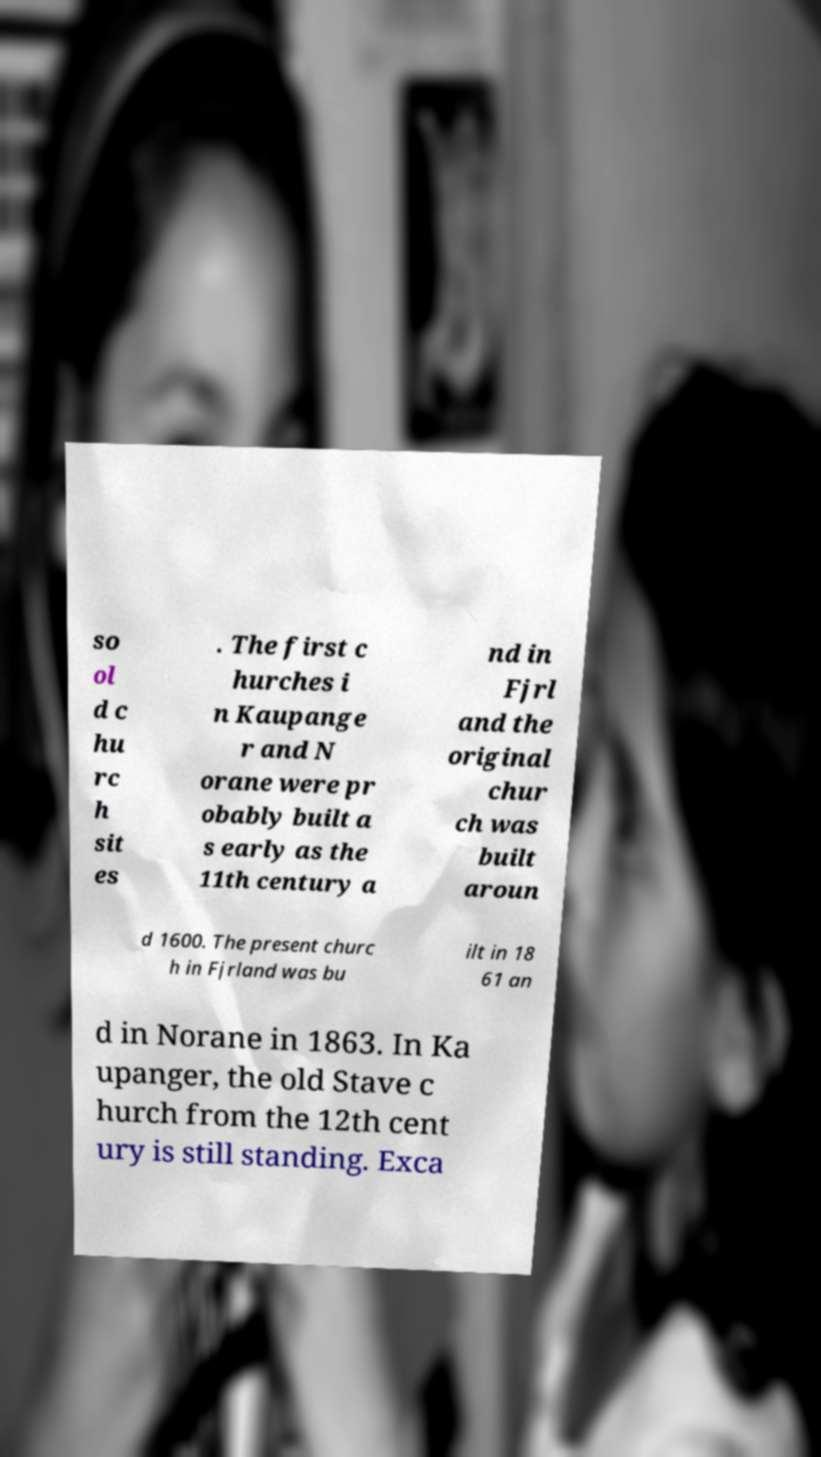Can you accurately transcribe the text from the provided image for me? so ol d c hu rc h sit es . The first c hurches i n Kaupange r and N orane were pr obably built a s early as the 11th century a nd in Fjrl and the original chur ch was built aroun d 1600. The present churc h in Fjrland was bu ilt in 18 61 an d in Norane in 1863. In Ka upanger, the old Stave c hurch from the 12th cent ury is still standing. Exca 